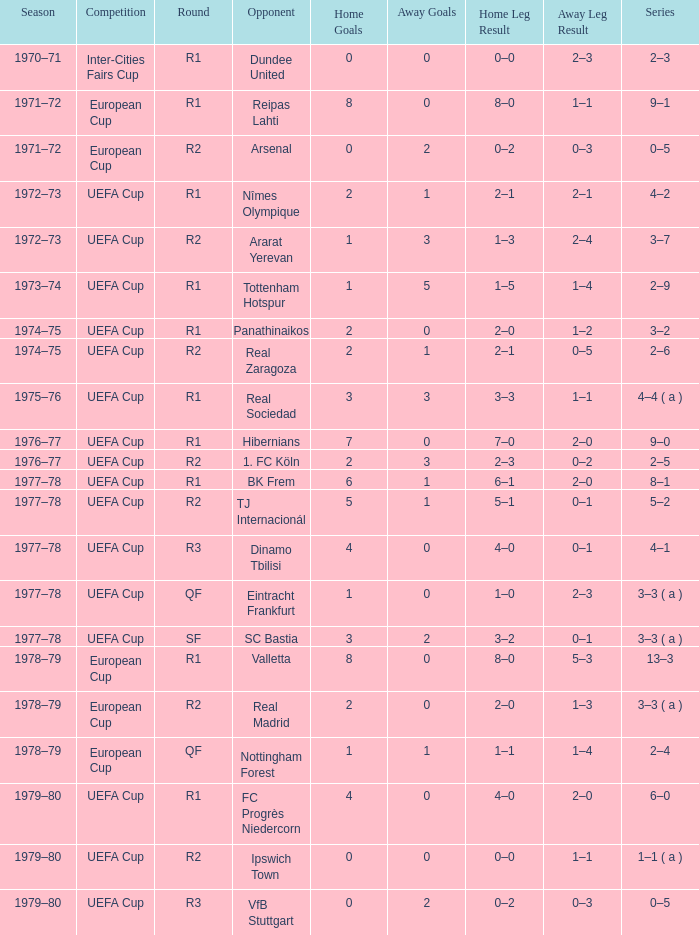Which Home has a Round of r1, and an Opponent of dundee united? 0–0. 